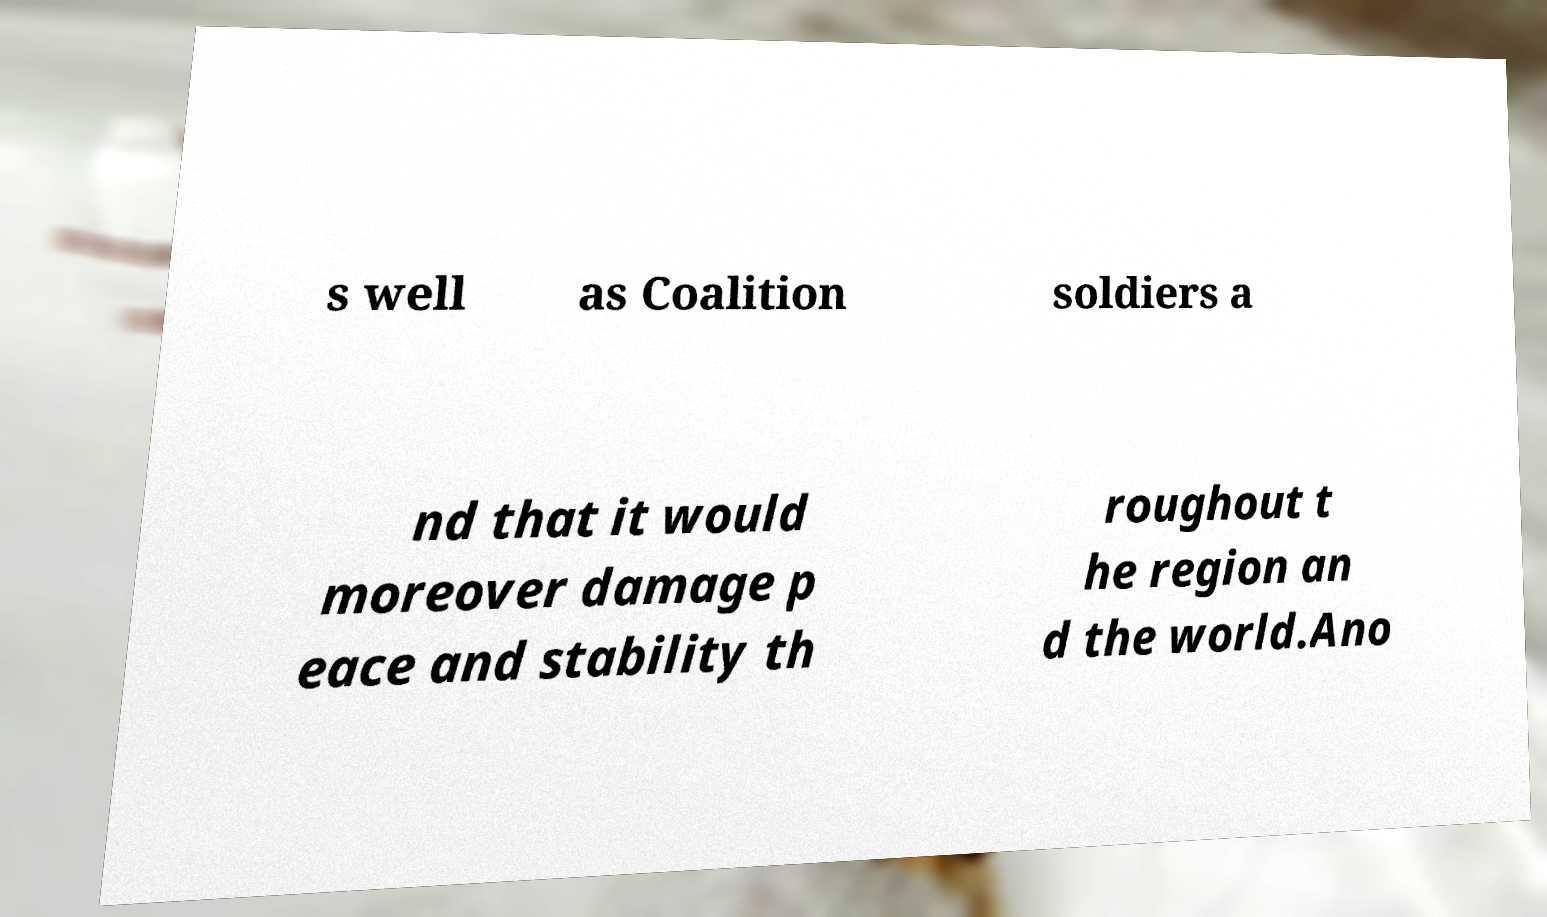Please read and relay the text visible in this image. What does it say? s well as Coalition soldiers a nd that it would moreover damage p eace and stability th roughout t he region an d the world.Ano 